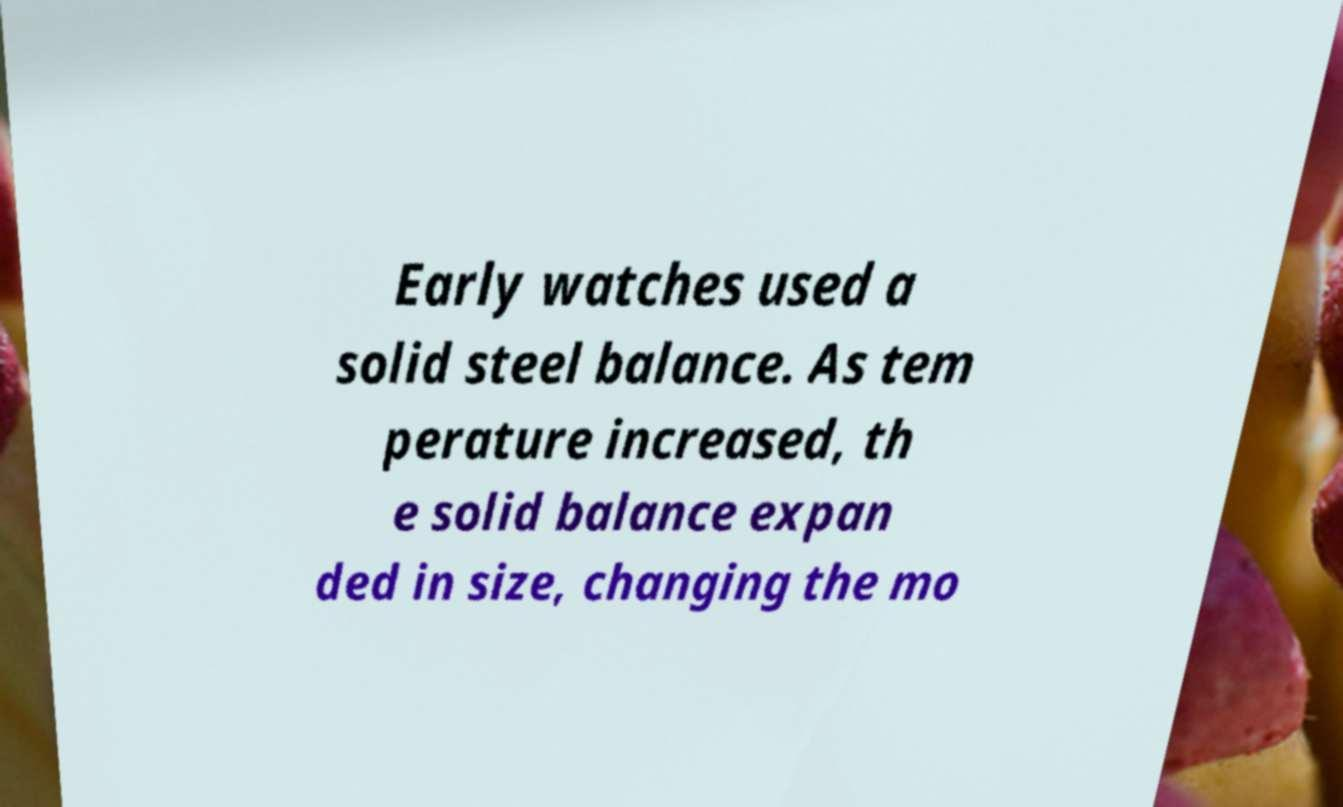For documentation purposes, I need the text within this image transcribed. Could you provide that? Early watches used a solid steel balance. As tem perature increased, th e solid balance expan ded in size, changing the mo 